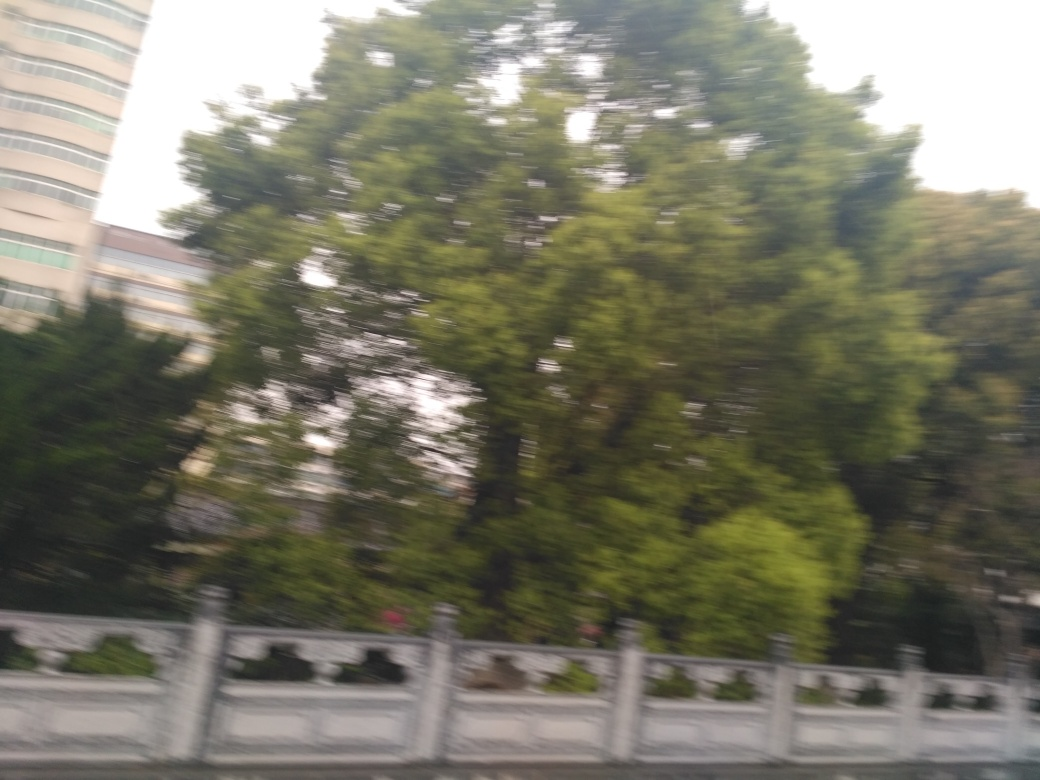Is it identifiable as a roadside guardrail and some trees?
A. No
B. Yes
Answer with the option's letter from the given choices directly.
 B. 